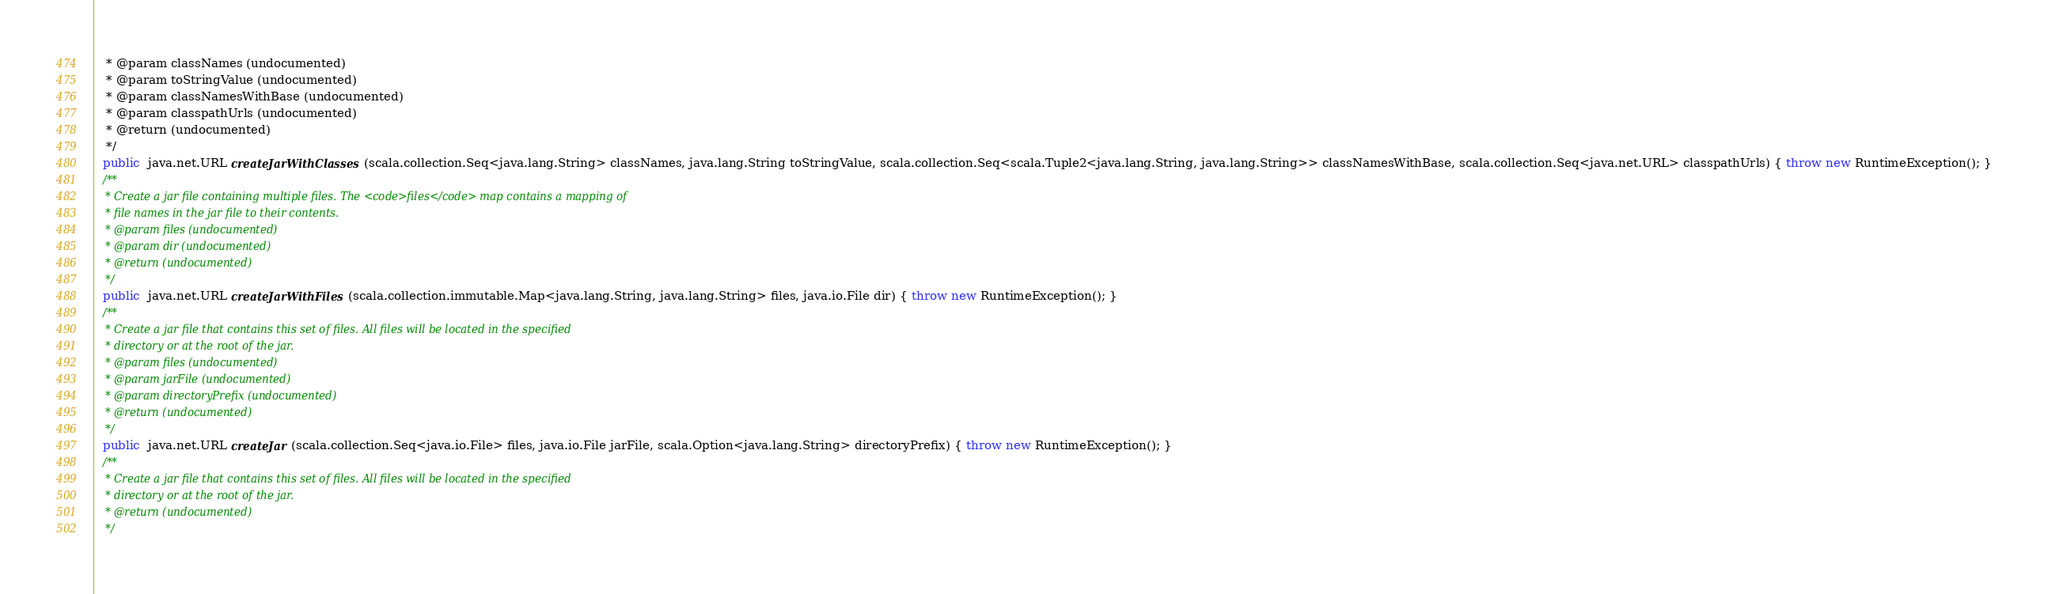<code> <loc_0><loc_0><loc_500><loc_500><_Java_>   * @param classNames (undocumented)
   * @param toStringValue (undocumented)
   * @param classNamesWithBase (undocumented)
   * @param classpathUrls (undocumented)
   * @return (undocumented)
   */
  public  java.net.URL createJarWithClasses (scala.collection.Seq<java.lang.String> classNames, java.lang.String toStringValue, scala.collection.Seq<scala.Tuple2<java.lang.String, java.lang.String>> classNamesWithBase, scala.collection.Seq<java.net.URL> classpathUrls) { throw new RuntimeException(); }
  /**
   * Create a jar file containing multiple files. The <code>files</code> map contains a mapping of
   * file names in the jar file to their contents.
   * @param files (undocumented)
   * @param dir (undocumented)
   * @return (undocumented)
   */
  public  java.net.URL createJarWithFiles (scala.collection.immutable.Map<java.lang.String, java.lang.String> files, java.io.File dir) { throw new RuntimeException(); }
  /**
   * Create a jar file that contains this set of files. All files will be located in the specified
   * directory or at the root of the jar.
   * @param files (undocumented)
   * @param jarFile (undocumented)
   * @param directoryPrefix (undocumented)
   * @return (undocumented)
   */
  public  java.net.URL createJar (scala.collection.Seq<java.io.File> files, java.io.File jarFile, scala.Option<java.lang.String> directoryPrefix) { throw new RuntimeException(); }
  /**
   * Create a jar file that contains this set of files. All files will be located in the specified
   * directory or at the root of the jar.
   * @return (undocumented)
   */</code> 